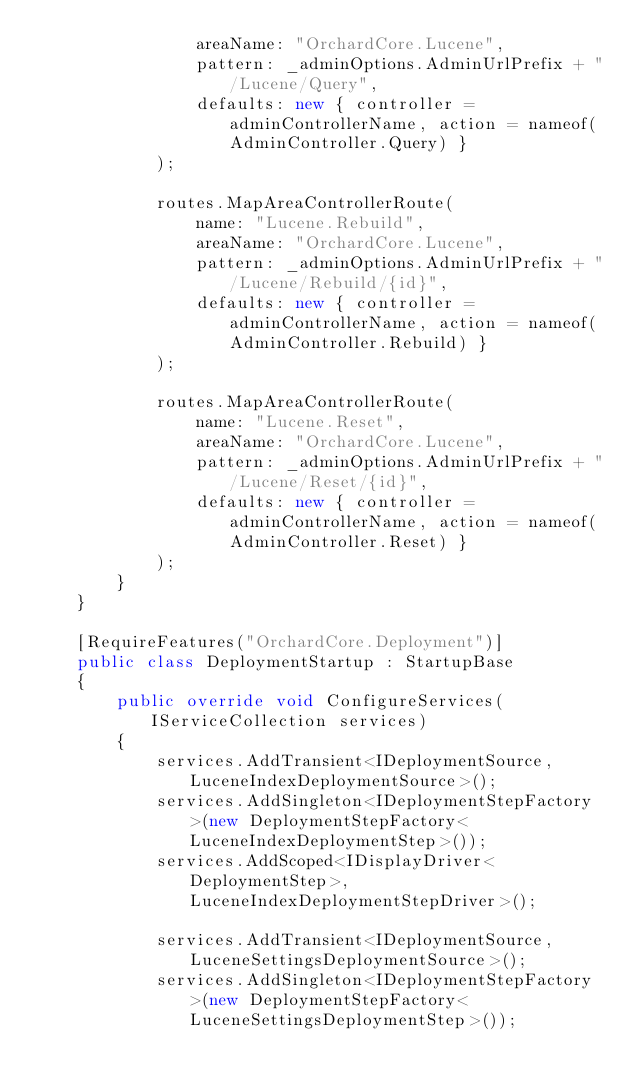Convert code to text. <code><loc_0><loc_0><loc_500><loc_500><_C#_>                areaName: "OrchardCore.Lucene",
                pattern: _adminOptions.AdminUrlPrefix + "/Lucene/Query",
                defaults: new { controller = adminControllerName, action = nameof(AdminController.Query) }
            );

            routes.MapAreaControllerRoute(
                name: "Lucene.Rebuild",
                areaName: "OrchardCore.Lucene",
                pattern: _adminOptions.AdminUrlPrefix + "/Lucene/Rebuild/{id}",
                defaults: new { controller = adminControllerName, action = nameof(AdminController.Rebuild) }
            );

            routes.MapAreaControllerRoute(
                name: "Lucene.Reset",
                areaName: "OrchardCore.Lucene",
                pattern: _adminOptions.AdminUrlPrefix + "/Lucene/Reset/{id}",
                defaults: new { controller = adminControllerName, action = nameof(AdminController.Reset) }
            );
        }
    }

    [RequireFeatures("OrchardCore.Deployment")]
    public class DeploymentStartup : StartupBase
    {
        public override void ConfigureServices(IServiceCollection services)
        {
            services.AddTransient<IDeploymentSource, LuceneIndexDeploymentSource>();
            services.AddSingleton<IDeploymentStepFactory>(new DeploymentStepFactory<LuceneIndexDeploymentStep>());
            services.AddScoped<IDisplayDriver<DeploymentStep>, LuceneIndexDeploymentStepDriver>();

            services.AddTransient<IDeploymentSource, LuceneSettingsDeploymentSource>();
            services.AddSingleton<IDeploymentStepFactory>(new DeploymentStepFactory<LuceneSettingsDeploymentStep>());</code> 